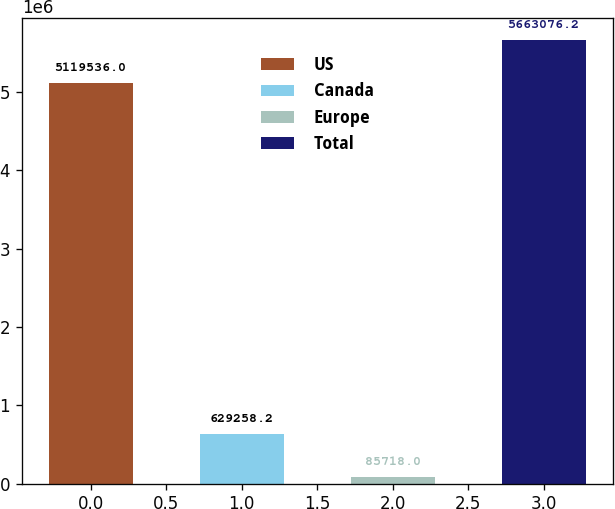<chart> <loc_0><loc_0><loc_500><loc_500><bar_chart><fcel>US<fcel>Canada<fcel>Europe<fcel>Total<nl><fcel>5.11954e+06<fcel>629258<fcel>85718<fcel>5.66308e+06<nl></chart> 